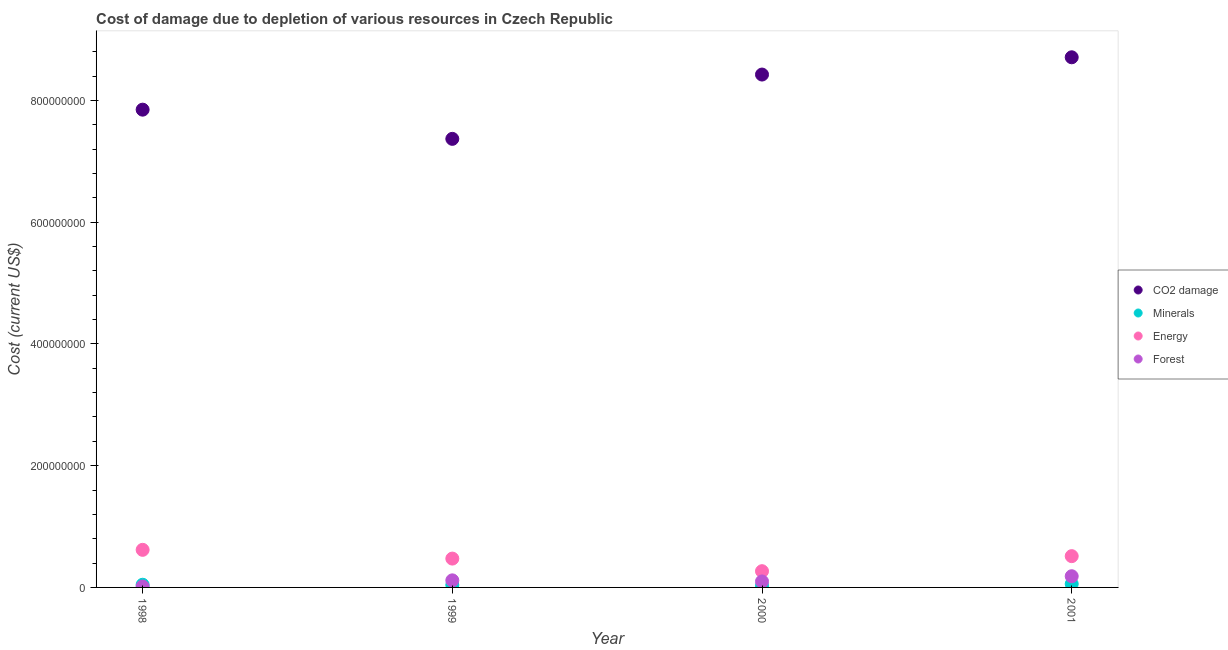How many different coloured dotlines are there?
Ensure brevity in your answer.  4. What is the cost of damage due to depletion of energy in 2001?
Keep it short and to the point. 5.14e+07. Across all years, what is the maximum cost of damage due to depletion of forests?
Offer a very short reply. 1.84e+07. Across all years, what is the minimum cost of damage due to depletion of coal?
Offer a very short reply. 7.37e+08. What is the total cost of damage due to depletion of energy in the graph?
Ensure brevity in your answer.  1.87e+08. What is the difference between the cost of damage due to depletion of forests in 2000 and that in 2001?
Make the answer very short. -8.57e+06. What is the difference between the cost of damage due to depletion of minerals in 2001 and the cost of damage due to depletion of forests in 1999?
Your answer should be very brief. -5.92e+06. What is the average cost of damage due to depletion of coal per year?
Your response must be concise. 8.09e+08. In the year 1998, what is the difference between the cost of damage due to depletion of forests and cost of damage due to depletion of coal?
Keep it short and to the point. -7.83e+08. In how many years, is the cost of damage due to depletion of minerals greater than 200000000 US$?
Give a very brief answer. 0. What is the ratio of the cost of damage due to depletion of minerals in 1999 to that in 2000?
Your response must be concise. 1.48. Is the difference between the cost of damage due to depletion of minerals in 1999 and 2001 greater than the difference between the cost of damage due to depletion of energy in 1999 and 2001?
Your response must be concise. Yes. What is the difference between the highest and the second highest cost of damage due to depletion of coal?
Make the answer very short. 2.84e+07. What is the difference between the highest and the lowest cost of damage due to depletion of energy?
Your answer should be very brief. 3.51e+07. In how many years, is the cost of damage due to depletion of minerals greater than the average cost of damage due to depletion of minerals taken over all years?
Your response must be concise. 2. Is it the case that in every year, the sum of the cost of damage due to depletion of coal and cost of damage due to depletion of minerals is greater than the cost of damage due to depletion of energy?
Your answer should be very brief. Yes. How many years are there in the graph?
Offer a terse response. 4. Does the graph contain any zero values?
Ensure brevity in your answer.  No. Does the graph contain grids?
Your answer should be very brief. No. Where does the legend appear in the graph?
Keep it short and to the point. Center right. What is the title of the graph?
Provide a short and direct response. Cost of damage due to depletion of various resources in Czech Republic . Does "Periodicity assessment" appear as one of the legend labels in the graph?
Keep it short and to the point. No. What is the label or title of the X-axis?
Provide a short and direct response. Year. What is the label or title of the Y-axis?
Offer a terse response. Cost (current US$). What is the Cost (current US$) of CO2 damage in 1998?
Ensure brevity in your answer.  7.85e+08. What is the Cost (current US$) of Minerals in 1998?
Offer a terse response. 4.40e+06. What is the Cost (current US$) in Energy in 1998?
Keep it short and to the point. 6.17e+07. What is the Cost (current US$) in Forest in 1998?
Provide a succinct answer. 1.50e+06. What is the Cost (current US$) of CO2 damage in 1999?
Keep it short and to the point. 7.37e+08. What is the Cost (current US$) in Minerals in 1999?
Make the answer very short. 3.98e+06. What is the Cost (current US$) of Energy in 1999?
Provide a succinct answer. 4.74e+07. What is the Cost (current US$) of Forest in 1999?
Provide a succinct answer. 1.16e+07. What is the Cost (current US$) in CO2 damage in 2000?
Your answer should be very brief. 8.42e+08. What is the Cost (current US$) of Minerals in 2000?
Give a very brief answer. 2.68e+06. What is the Cost (current US$) in Energy in 2000?
Your response must be concise. 2.67e+07. What is the Cost (current US$) in Forest in 2000?
Make the answer very short. 9.82e+06. What is the Cost (current US$) of CO2 damage in 2001?
Your answer should be compact. 8.71e+08. What is the Cost (current US$) in Minerals in 2001?
Keep it short and to the point. 5.69e+06. What is the Cost (current US$) in Energy in 2001?
Ensure brevity in your answer.  5.14e+07. What is the Cost (current US$) in Forest in 2001?
Give a very brief answer. 1.84e+07. Across all years, what is the maximum Cost (current US$) in CO2 damage?
Ensure brevity in your answer.  8.71e+08. Across all years, what is the maximum Cost (current US$) in Minerals?
Keep it short and to the point. 5.69e+06. Across all years, what is the maximum Cost (current US$) in Energy?
Ensure brevity in your answer.  6.17e+07. Across all years, what is the maximum Cost (current US$) in Forest?
Make the answer very short. 1.84e+07. Across all years, what is the minimum Cost (current US$) of CO2 damage?
Keep it short and to the point. 7.37e+08. Across all years, what is the minimum Cost (current US$) in Minerals?
Give a very brief answer. 2.68e+06. Across all years, what is the minimum Cost (current US$) in Energy?
Your answer should be very brief. 2.67e+07. Across all years, what is the minimum Cost (current US$) of Forest?
Give a very brief answer. 1.50e+06. What is the total Cost (current US$) in CO2 damage in the graph?
Ensure brevity in your answer.  3.23e+09. What is the total Cost (current US$) in Minerals in the graph?
Your response must be concise. 1.67e+07. What is the total Cost (current US$) of Energy in the graph?
Your answer should be very brief. 1.87e+08. What is the total Cost (current US$) of Forest in the graph?
Make the answer very short. 4.13e+07. What is the difference between the Cost (current US$) of CO2 damage in 1998 and that in 1999?
Your answer should be compact. 4.79e+07. What is the difference between the Cost (current US$) in Minerals in 1998 and that in 1999?
Ensure brevity in your answer.  4.21e+05. What is the difference between the Cost (current US$) of Energy in 1998 and that in 1999?
Offer a terse response. 1.44e+07. What is the difference between the Cost (current US$) of Forest in 1998 and that in 1999?
Keep it short and to the point. -1.01e+07. What is the difference between the Cost (current US$) of CO2 damage in 1998 and that in 2000?
Your response must be concise. -5.77e+07. What is the difference between the Cost (current US$) of Minerals in 1998 and that in 2000?
Ensure brevity in your answer.  1.72e+06. What is the difference between the Cost (current US$) of Energy in 1998 and that in 2000?
Your response must be concise. 3.51e+07. What is the difference between the Cost (current US$) in Forest in 1998 and that in 2000?
Offer a very short reply. -8.32e+06. What is the difference between the Cost (current US$) of CO2 damage in 1998 and that in 2001?
Offer a very short reply. -8.60e+07. What is the difference between the Cost (current US$) of Minerals in 1998 and that in 2001?
Provide a succinct answer. -1.29e+06. What is the difference between the Cost (current US$) in Energy in 1998 and that in 2001?
Provide a short and direct response. 1.04e+07. What is the difference between the Cost (current US$) of Forest in 1998 and that in 2001?
Ensure brevity in your answer.  -1.69e+07. What is the difference between the Cost (current US$) of CO2 damage in 1999 and that in 2000?
Offer a very short reply. -1.06e+08. What is the difference between the Cost (current US$) of Minerals in 1999 and that in 2000?
Keep it short and to the point. 1.30e+06. What is the difference between the Cost (current US$) in Energy in 1999 and that in 2000?
Give a very brief answer. 2.07e+07. What is the difference between the Cost (current US$) in Forest in 1999 and that in 2000?
Give a very brief answer. 1.79e+06. What is the difference between the Cost (current US$) in CO2 damage in 1999 and that in 2001?
Your response must be concise. -1.34e+08. What is the difference between the Cost (current US$) in Minerals in 1999 and that in 2001?
Offer a terse response. -1.71e+06. What is the difference between the Cost (current US$) of Energy in 1999 and that in 2001?
Offer a very short reply. -4.01e+06. What is the difference between the Cost (current US$) of Forest in 1999 and that in 2001?
Provide a short and direct response. -6.77e+06. What is the difference between the Cost (current US$) of CO2 damage in 2000 and that in 2001?
Offer a very short reply. -2.84e+07. What is the difference between the Cost (current US$) of Minerals in 2000 and that in 2001?
Your response must be concise. -3.01e+06. What is the difference between the Cost (current US$) in Energy in 2000 and that in 2001?
Provide a short and direct response. -2.47e+07. What is the difference between the Cost (current US$) of Forest in 2000 and that in 2001?
Ensure brevity in your answer.  -8.57e+06. What is the difference between the Cost (current US$) in CO2 damage in 1998 and the Cost (current US$) in Minerals in 1999?
Your answer should be compact. 7.81e+08. What is the difference between the Cost (current US$) of CO2 damage in 1998 and the Cost (current US$) of Energy in 1999?
Offer a very short reply. 7.37e+08. What is the difference between the Cost (current US$) of CO2 damage in 1998 and the Cost (current US$) of Forest in 1999?
Your response must be concise. 7.73e+08. What is the difference between the Cost (current US$) of Minerals in 1998 and the Cost (current US$) of Energy in 1999?
Provide a succinct answer. -4.30e+07. What is the difference between the Cost (current US$) of Minerals in 1998 and the Cost (current US$) of Forest in 1999?
Keep it short and to the point. -7.21e+06. What is the difference between the Cost (current US$) in Energy in 1998 and the Cost (current US$) in Forest in 1999?
Give a very brief answer. 5.01e+07. What is the difference between the Cost (current US$) in CO2 damage in 1998 and the Cost (current US$) in Minerals in 2000?
Your answer should be very brief. 7.82e+08. What is the difference between the Cost (current US$) of CO2 damage in 1998 and the Cost (current US$) of Energy in 2000?
Ensure brevity in your answer.  7.58e+08. What is the difference between the Cost (current US$) in CO2 damage in 1998 and the Cost (current US$) in Forest in 2000?
Provide a short and direct response. 7.75e+08. What is the difference between the Cost (current US$) of Minerals in 1998 and the Cost (current US$) of Energy in 2000?
Your response must be concise. -2.23e+07. What is the difference between the Cost (current US$) of Minerals in 1998 and the Cost (current US$) of Forest in 2000?
Give a very brief answer. -5.42e+06. What is the difference between the Cost (current US$) of Energy in 1998 and the Cost (current US$) of Forest in 2000?
Make the answer very short. 5.19e+07. What is the difference between the Cost (current US$) of CO2 damage in 1998 and the Cost (current US$) of Minerals in 2001?
Give a very brief answer. 7.79e+08. What is the difference between the Cost (current US$) of CO2 damage in 1998 and the Cost (current US$) of Energy in 2001?
Ensure brevity in your answer.  7.33e+08. What is the difference between the Cost (current US$) in CO2 damage in 1998 and the Cost (current US$) in Forest in 2001?
Keep it short and to the point. 7.66e+08. What is the difference between the Cost (current US$) in Minerals in 1998 and the Cost (current US$) in Energy in 2001?
Your response must be concise. -4.70e+07. What is the difference between the Cost (current US$) in Minerals in 1998 and the Cost (current US$) in Forest in 2001?
Keep it short and to the point. -1.40e+07. What is the difference between the Cost (current US$) of Energy in 1998 and the Cost (current US$) of Forest in 2001?
Your answer should be very brief. 4.34e+07. What is the difference between the Cost (current US$) in CO2 damage in 1999 and the Cost (current US$) in Minerals in 2000?
Keep it short and to the point. 7.34e+08. What is the difference between the Cost (current US$) in CO2 damage in 1999 and the Cost (current US$) in Energy in 2000?
Your response must be concise. 7.10e+08. What is the difference between the Cost (current US$) in CO2 damage in 1999 and the Cost (current US$) in Forest in 2000?
Provide a succinct answer. 7.27e+08. What is the difference between the Cost (current US$) of Minerals in 1999 and the Cost (current US$) of Energy in 2000?
Provide a short and direct response. -2.27e+07. What is the difference between the Cost (current US$) in Minerals in 1999 and the Cost (current US$) in Forest in 2000?
Keep it short and to the point. -5.84e+06. What is the difference between the Cost (current US$) in Energy in 1999 and the Cost (current US$) in Forest in 2000?
Your response must be concise. 3.75e+07. What is the difference between the Cost (current US$) in CO2 damage in 1999 and the Cost (current US$) in Minerals in 2001?
Your answer should be very brief. 7.31e+08. What is the difference between the Cost (current US$) in CO2 damage in 1999 and the Cost (current US$) in Energy in 2001?
Offer a terse response. 6.85e+08. What is the difference between the Cost (current US$) in CO2 damage in 1999 and the Cost (current US$) in Forest in 2001?
Provide a short and direct response. 7.18e+08. What is the difference between the Cost (current US$) of Minerals in 1999 and the Cost (current US$) of Energy in 2001?
Offer a terse response. -4.74e+07. What is the difference between the Cost (current US$) in Minerals in 1999 and the Cost (current US$) in Forest in 2001?
Your response must be concise. -1.44e+07. What is the difference between the Cost (current US$) of Energy in 1999 and the Cost (current US$) of Forest in 2001?
Your answer should be compact. 2.90e+07. What is the difference between the Cost (current US$) in CO2 damage in 2000 and the Cost (current US$) in Minerals in 2001?
Give a very brief answer. 8.37e+08. What is the difference between the Cost (current US$) in CO2 damage in 2000 and the Cost (current US$) in Energy in 2001?
Provide a short and direct response. 7.91e+08. What is the difference between the Cost (current US$) in CO2 damage in 2000 and the Cost (current US$) in Forest in 2001?
Offer a very short reply. 8.24e+08. What is the difference between the Cost (current US$) of Minerals in 2000 and the Cost (current US$) of Energy in 2001?
Your response must be concise. -4.87e+07. What is the difference between the Cost (current US$) of Minerals in 2000 and the Cost (current US$) of Forest in 2001?
Offer a very short reply. -1.57e+07. What is the difference between the Cost (current US$) of Energy in 2000 and the Cost (current US$) of Forest in 2001?
Offer a very short reply. 8.30e+06. What is the average Cost (current US$) in CO2 damage per year?
Ensure brevity in your answer.  8.09e+08. What is the average Cost (current US$) of Minerals per year?
Your response must be concise. 4.19e+06. What is the average Cost (current US$) of Energy per year?
Provide a succinct answer. 4.68e+07. What is the average Cost (current US$) in Forest per year?
Provide a succinct answer. 1.03e+07. In the year 1998, what is the difference between the Cost (current US$) of CO2 damage and Cost (current US$) of Minerals?
Ensure brevity in your answer.  7.80e+08. In the year 1998, what is the difference between the Cost (current US$) of CO2 damage and Cost (current US$) of Energy?
Provide a short and direct response. 7.23e+08. In the year 1998, what is the difference between the Cost (current US$) in CO2 damage and Cost (current US$) in Forest?
Keep it short and to the point. 7.83e+08. In the year 1998, what is the difference between the Cost (current US$) in Minerals and Cost (current US$) in Energy?
Keep it short and to the point. -5.73e+07. In the year 1998, what is the difference between the Cost (current US$) in Minerals and Cost (current US$) in Forest?
Give a very brief answer. 2.90e+06. In the year 1998, what is the difference between the Cost (current US$) of Energy and Cost (current US$) of Forest?
Give a very brief answer. 6.02e+07. In the year 1999, what is the difference between the Cost (current US$) in CO2 damage and Cost (current US$) in Minerals?
Give a very brief answer. 7.33e+08. In the year 1999, what is the difference between the Cost (current US$) in CO2 damage and Cost (current US$) in Energy?
Your answer should be compact. 6.89e+08. In the year 1999, what is the difference between the Cost (current US$) of CO2 damage and Cost (current US$) of Forest?
Keep it short and to the point. 7.25e+08. In the year 1999, what is the difference between the Cost (current US$) in Minerals and Cost (current US$) in Energy?
Offer a terse response. -4.34e+07. In the year 1999, what is the difference between the Cost (current US$) in Minerals and Cost (current US$) in Forest?
Ensure brevity in your answer.  -7.63e+06. In the year 1999, what is the difference between the Cost (current US$) in Energy and Cost (current US$) in Forest?
Make the answer very short. 3.57e+07. In the year 2000, what is the difference between the Cost (current US$) of CO2 damage and Cost (current US$) of Minerals?
Ensure brevity in your answer.  8.40e+08. In the year 2000, what is the difference between the Cost (current US$) in CO2 damage and Cost (current US$) in Energy?
Offer a terse response. 8.16e+08. In the year 2000, what is the difference between the Cost (current US$) of CO2 damage and Cost (current US$) of Forest?
Give a very brief answer. 8.33e+08. In the year 2000, what is the difference between the Cost (current US$) of Minerals and Cost (current US$) of Energy?
Give a very brief answer. -2.40e+07. In the year 2000, what is the difference between the Cost (current US$) in Minerals and Cost (current US$) in Forest?
Keep it short and to the point. -7.14e+06. In the year 2000, what is the difference between the Cost (current US$) of Energy and Cost (current US$) of Forest?
Make the answer very short. 1.69e+07. In the year 2001, what is the difference between the Cost (current US$) of CO2 damage and Cost (current US$) of Minerals?
Make the answer very short. 8.65e+08. In the year 2001, what is the difference between the Cost (current US$) of CO2 damage and Cost (current US$) of Energy?
Your answer should be very brief. 8.19e+08. In the year 2001, what is the difference between the Cost (current US$) of CO2 damage and Cost (current US$) of Forest?
Give a very brief answer. 8.52e+08. In the year 2001, what is the difference between the Cost (current US$) of Minerals and Cost (current US$) of Energy?
Provide a short and direct response. -4.57e+07. In the year 2001, what is the difference between the Cost (current US$) of Minerals and Cost (current US$) of Forest?
Offer a very short reply. -1.27e+07. In the year 2001, what is the difference between the Cost (current US$) in Energy and Cost (current US$) in Forest?
Keep it short and to the point. 3.30e+07. What is the ratio of the Cost (current US$) of CO2 damage in 1998 to that in 1999?
Offer a very short reply. 1.07. What is the ratio of the Cost (current US$) of Minerals in 1998 to that in 1999?
Your response must be concise. 1.11. What is the ratio of the Cost (current US$) of Energy in 1998 to that in 1999?
Your answer should be compact. 1.3. What is the ratio of the Cost (current US$) in Forest in 1998 to that in 1999?
Give a very brief answer. 0.13. What is the ratio of the Cost (current US$) of CO2 damage in 1998 to that in 2000?
Provide a short and direct response. 0.93. What is the ratio of the Cost (current US$) of Minerals in 1998 to that in 2000?
Offer a very short reply. 1.64. What is the ratio of the Cost (current US$) in Energy in 1998 to that in 2000?
Offer a very short reply. 2.31. What is the ratio of the Cost (current US$) of Forest in 1998 to that in 2000?
Your response must be concise. 0.15. What is the ratio of the Cost (current US$) in CO2 damage in 1998 to that in 2001?
Provide a succinct answer. 0.9. What is the ratio of the Cost (current US$) in Minerals in 1998 to that in 2001?
Offer a terse response. 0.77. What is the ratio of the Cost (current US$) of Energy in 1998 to that in 2001?
Your answer should be very brief. 1.2. What is the ratio of the Cost (current US$) of Forest in 1998 to that in 2001?
Give a very brief answer. 0.08. What is the ratio of the Cost (current US$) of CO2 damage in 1999 to that in 2000?
Make the answer very short. 0.87. What is the ratio of the Cost (current US$) in Minerals in 1999 to that in 2000?
Your answer should be very brief. 1.48. What is the ratio of the Cost (current US$) of Energy in 1999 to that in 2000?
Make the answer very short. 1.77. What is the ratio of the Cost (current US$) in Forest in 1999 to that in 2000?
Keep it short and to the point. 1.18. What is the ratio of the Cost (current US$) in CO2 damage in 1999 to that in 2001?
Provide a succinct answer. 0.85. What is the ratio of the Cost (current US$) in Minerals in 1999 to that in 2001?
Offer a terse response. 0.7. What is the ratio of the Cost (current US$) in Energy in 1999 to that in 2001?
Offer a terse response. 0.92. What is the ratio of the Cost (current US$) of Forest in 1999 to that in 2001?
Provide a succinct answer. 0.63. What is the ratio of the Cost (current US$) of CO2 damage in 2000 to that in 2001?
Keep it short and to the point. 0.97. What is the ratio of the Cost (current US$) of Minerals in 2000 to that in 2001?
Offer a terse response. 0.47. What is the ratio of the Cost (current US$) in Energy in 2000 to that in 2001?
Make the answer very short. 0.52. What is the ratio of the Cost (current US$) in Forest in 2000 to that in 2001?
Provide a succinct answer. 0.53. What is the difference between the highest and the second highest Cost (current US$) of CO2 damage?
Offer a very short reply. 2.84e+07. What is the difference between the highest and the second highest Cost (current US$) in Minerals?
Make the answer very short. 1.29e+06. What is the difference between the highest and the second highest Cost (current US$) in Energy?
Your response must be concise. 1.04e+07. What is the difference between the highest and the second highest Cost (current US$) of Forest?
Ensure brevity in your answer.  6.77e+06. What is the difference between the highest and the lowest Cost (current US$) in CO2 damage?
Keep it short and to the point. 1.34e+08. What is the difference between the highest and the lowest Cost (current US$) of Minerals?
Offer a very short reply. 3.01e+06. What is the difference between the highest and the lowest Cost (current US$) in Energy?
Make the answer very short. 3.51e+07. What is the difference between the highest and the lowest Cost (current US$) in Forest?
Your response must be concise. 1.69e+07. 